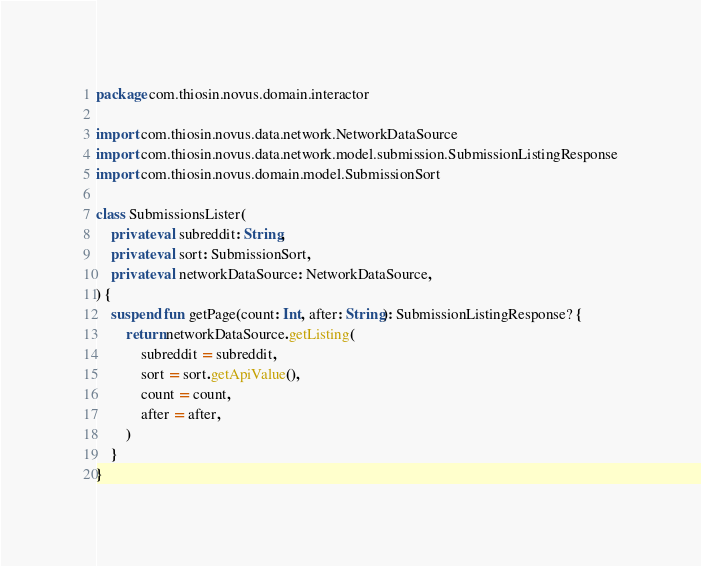Convert code to text. <code><loc_0><loc_0><loc_500><loc_500><_Kotlin_>package com.thiosin.novus.domain.interactor

import com.thiosin.novus.data.network.NetworkDataSource
import com.thiosin.novus.data.network.model.submission.SubmissionListingResponse
import com.thiosin.novus.domain.model.SubmissionSort

class SubmissionsLister(
    private val subreddit: String,
    private val sort: SubmissionSort,
    private val networkDataSource: NetworkDataSource,
) {
    suspend fun getPage(count: Int, after: String): SubmissionListingResponse? {
        return networkDataSource.getListing(
            subreddit = subreddit,
            sort = sort.getApiValue(),
            count = count,
            after = after,
        )
    }
}
</code> 